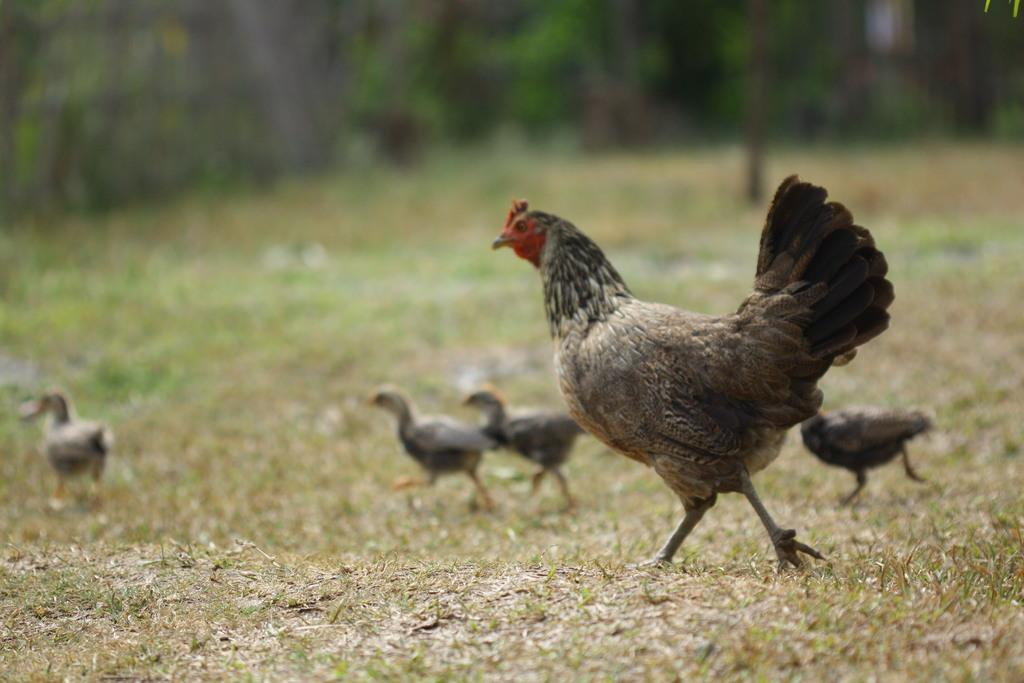Where was the image taken? The image was clicked outside. What animals can be seen in the image? There are hens in the image. Can you describe the hens in the image? The hens are of different sizes. What color is the daughter's pin in the image? There is no daughter or pin present in the image; it features hens of different sizes. 